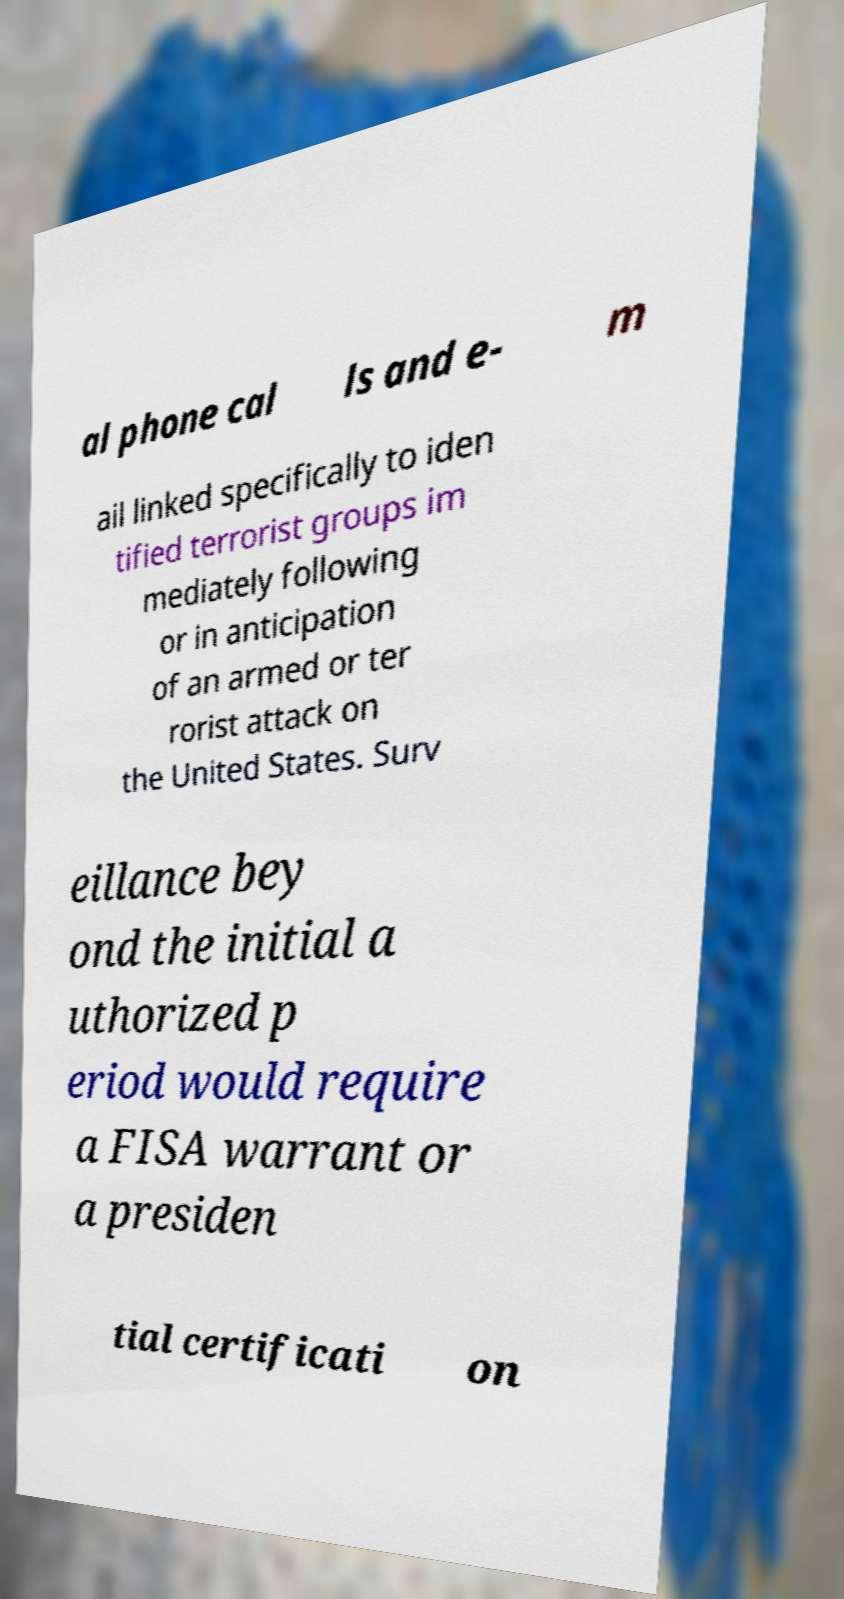Can you read and provide the text displayed in the image?This photo seems to have some interesting text. Can you extract and type it out for me? al phone cal ls and e- m ail linked specifically to iden tified terrorist groups im mediately following or in anticipation of an armed or ter rorist attack on the United States. Surv eillance bey ond the initial a uthorized p eriod would require a FISA warrant or a presiden tial certificati on 